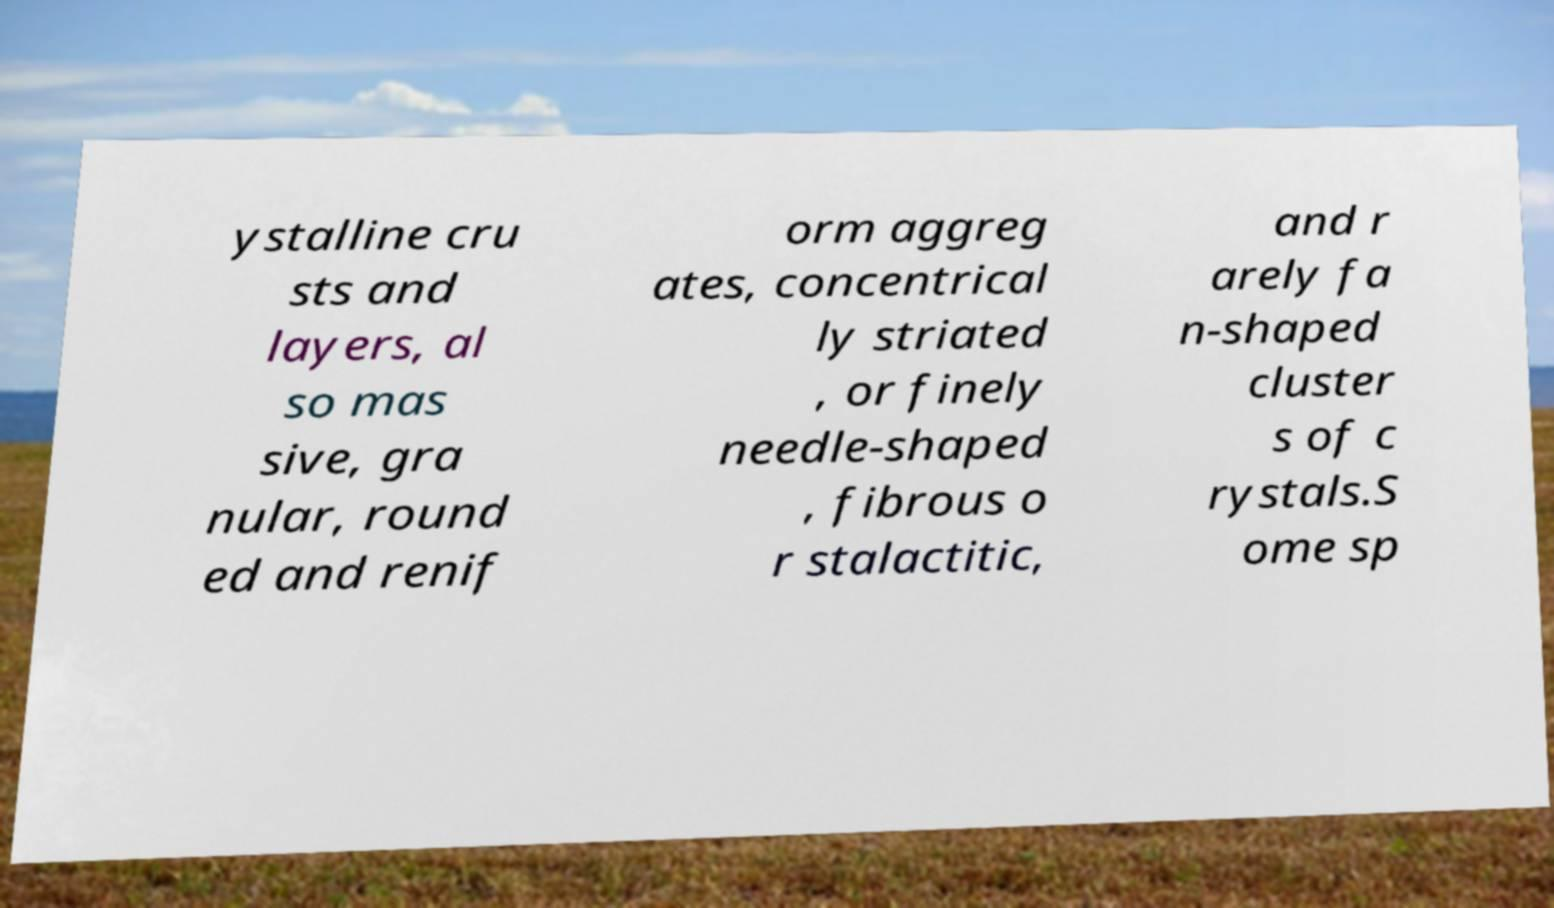What messages or text are displayed in this image? I need them in a readable, typed format. ystalline cru sts and layers, al so mas sive, gra nular, round ed and renif orm aggreg ates, concentrical ly striated , or finely needle-shaped , fibrous o r stalactitic, and r arely fa n-shaped cluster s of c rystals.S ome sp 